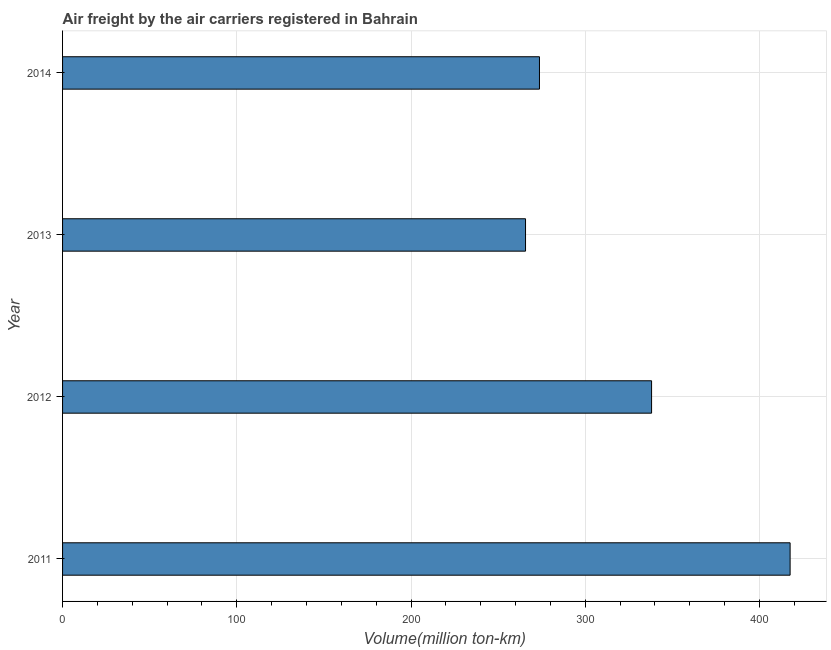Does the graph contain any zero values?
Offer a terse response. No. What is the title of the graph?
Provide a short and direct response. Air freight by the air carriers registered in Bahrain. What is the label or title of the X-axis?
Offer a very short reply. Volume(million ton-km). What is the air freight in 2012?
Provide a succinct answer. 338.07. Across all years, what is the maximum air freight?
Your answer should be very brief. 417.58. Across all years, what is the minimum air freight?
Your answer should be compact. 265.73. In which year was the air freight maximum?
Ensure brevity in your answer.  2011. In which year was the air freight minimum?
Ensure brevity in your answer.  2013. What is the sum of the air freight?
Give a very brief answer. 1295.11. What is the difference between the air freight in 2011 and 2013?
Make the answer very short. 151.86. What is the average air freight per year?
Offer a terse response. 323.78. What is the median air freight?
Ensure brevity in your answer.  305.9. Is the air freight in 2011 less than that in 2014?
Your answer should be compact. No. What is the difference between the highest and the second highest air freight?
Make the answer very short. 79.51. What is the difference between the highest and the lowest air freight?
Offer a very short reply. 151.86. In how many years, is the air freight greater than the average air freight taken over all years?
Make the answer very short. 2. What is the difference between two consecutive major ticks on the X-axis?
Ensure brevity in your answer.  100. What is the Volume(million ton-km) of 2011?
Your answer should be very brief. 417.58. What is the Volume(million ton-km) in 2012?
Your answer should be very brief. 338.07. What is the Volume(million ton-km) of 2013?
Provide a succinct answer. 265.73. What is the Volume(million ton-km) in 2014?
Keep it short and to the point. 273.73. What is the difference between the Volume(million ton-km) in 2011 and 2012?
Provide a succinct answer. 79.51. What is the difference between the Volume(million ton-km) in 2011 and 2013?
Keep it short and to the point. 151.86. What is the difference between the Volume(million ton-km) in 2011 and 2014?
Ensure brevity in your answer.  143.86. What is the difference between the Volume(million ton-km) in 2012 and 2013?
Give a very brief answer. 72.34. What is the difference between the Volume(million ton-km) in 2012 and 2014?
Provide a succinct answer. 64.35. What is the difference between the Volume(million ton-km) in 2013 and 2014?
Offer a terse response. -8. What is the ratio of the Volume(million ton-km) in 2011 to that in 2012?
Your answer should be compact. 1.24. What is the ratio of the Volume(million ton-km) in 2011 to that in 2013?
Your response must be concise. 1.57. What is the ratio of the Volume(million ton-km) in 2011 to that in 2014?
Your response must be concise. 1.53. What is the ratio of the Volume(million ton-km) in 2012 to that in 2013?
Your answer should be very brief. 1.27. What is the ratio of the Volume(million ton-km) in 2012 to that in 2014?
Keep it short and to the point. 1.24. 